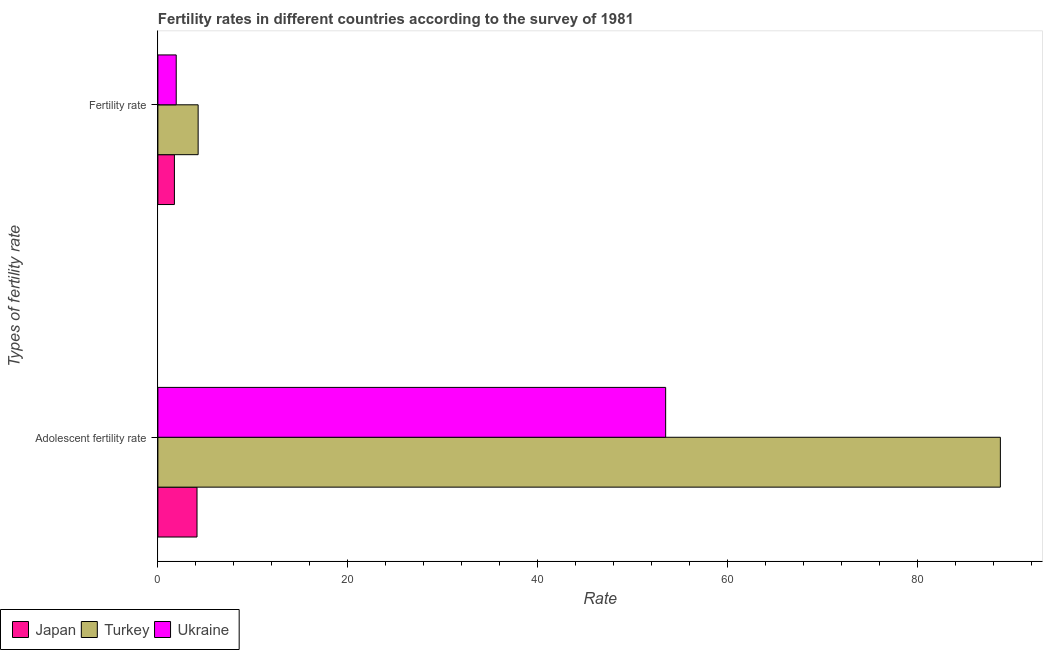How many different coloured bars are there?
Your answer should be very brief. 3. How many groups of bars are there?
Provide a short and direct response. 2. Are the number of bars on each tick of the Y-axis equal?
Provide a succinct answer. Yes. How many bars are there on the 1st tick from the bottom?
Provide a short and direct response. 3. What is the label of the 2nd group of bars from the top?
Your answer should be very brief. Adolescent fertility rate. What is the fertility rate in Turkey?
Ensure brevity in your answer.  4.24. Across all countries, what is the maximum fertility rate?
Offer a terse response. 4.24. Across all countries, what is the minimum fertility rate?
Provide a short and direct response. 1.74. In which country was the adolescent fertility rate maximum?
Your answer should be compact. Turkey. What is the total fertility rate in the graph?
Offer a terse response. 7.91. What is the difference between the fertility rate in Japan and that in Turkey?
Make the answer very short. -2.5. What is the difference between the adolescent fertility rate in Japan and the fertility rate in Turkey?
Give a very brief answer. -0.12. What is the average adolescent fertility rate per country?
Provide a succinct answer. 48.78. What is the difference between the fertility rate and adolescent fertility rate in Japan?
Give a very brief answer. -2.38. What is the ratio of the adolescent fertility rate in Ukraine to that in Turkey?
Offer a terse response. 0.6. Is the fertility rate in Japan less than that in Turkey?
Your response must be concise. Yes. What does the 3rd bar from the top in Adolescent fertility rate represents?
Keep it short and to the point. Japan. What does the 3rd bar from the bottom in Adolescent fertility rate represents?
Provide a succinct answer. Ukraine. What is the difference between two consecutive major ticks on the X-axis?
Make the answer very short. 20. Are the values on the major ticks of X-axis written in scientific E-notation?
Offer a terse response. No. Does the graph contain grids?
Make the answer very short. No. Where does the legend appear in the graph?
Offer a very short reply. Bottom left. How many legend labels are there?
Ensure brevity in your answer.  3. How are the legend labels stacked?
Your answer should be very brief. Horizontal. What is the title of the graph?
Your response must be concise. Fertility rates in different countries according to the survey of 1981. What is the label or title of the X-axis?
Provide a short and direct response. Rate. What is the label or title of the Y-axis?
Provide a succinct answer. Types of fertility rate. What is the Rate in Japan in Adolescent fertility rate?
Your answer should be compact. 4.12. What is the Rate in Turkey in Adolescent fertility rate?
Your response must be concise. 88.73. What is the Rate in Ukraine in Adolescent fertility rate?
Provide a succinct answer. 53.48. What is the Rate in Japan in Fertility rate?
Your response must be concise. 1.74. What is the Rate of Turkey in Fertility rate?
Keep it short and to the point. 4.24. What is the Rate in Ukraine in Fertility rate?
Keep it short and to the point. 1.93. Across all Types of fertility rate, what is the maximum Rate of Japan?
Ensure brevity in your answer.  4.12. Across all Types of fertility rate, what is the maximum Rate in Turkey?
Ensure brevity in your answer.  88.73. Across all Types of fertility rate, what is the maximum Rate of Ukraine?
Make the answer very short. 53.48. Across all Types of fertility rate, what is the minimum Rate in Japan?
Your answer should be compact. 1.74. Across all Types of fertility rate, what is the minimum Rate in Turkey?
Provide a succinct answer. 4.24. Across all Types of fertility rate, what is the minimum Rate of Ukraine?
Your response must be concise. 1.93. What is the total Rate in Japan in the graph?
Ensure brevity in your answer.  5.86. What is the total Rate in Turkey in the graph?
Ensure brevity in your answer.  92.97. What is the total Rate of Ukraine in the graph?
Offer a very short reply. 55.41. What is the difference between the Rate of Japan in Adolescent fertility rate and that in Fertility rate?
Ensure brevity in your answer.  2.38. What is the difference between the Rate in Turkey in Adolescent fertility rate and that in Fertility rate?
Offer a terse response. 84.5. What is the difference between the Rate of Ukraine in Adolescent fertility rate and that in Fertility rate?
Ensure brevity in your answer.  51.55. What is the difference between the Rate in Japan in Adolescent fertility rate and the Rate in Turkey in Fertility rate?
Offer a terse response. -0.12. What is the difference between the Rate in Japan in Adolescent fertility rate and the Rate in Ukraine in Fertility rate?
Your response must be concise. 2.19. What is the difference between the Rate of Turkey in Adolescent fertility rate and the Rate of Ukraine in Fertility rate?
Offer a very short reply. 86.8. What is the average Rate in Japan per Types of fertility rate?
Your response must be concise. 2.93. What is the average Rate of Turkey per Types of fertility rate?
Provide a succinct answer. 46.49. What is the average Rate of Ukraine per Types of fertility rate?
Keep it short and to the point. 27.71. What is the difference between the Rate in Japan and Rate in Turkey in Adolescent fertility rate?
Offer a very short reply. -84.61. What is the difference between the Rate in Japan and Rate in Ukraine in Adolescent fertility rate?
Ensure brevity in your answer.  -49.36. What is the difference between the Rate of Turkey and Rate of Ukraine in Adolescent fertility rate?
Offer a very short reply. 35.25. What is the difference between the Rate of Japan and Rate of Turkey in Fertility rate?
Offer a very short reply. -2.5. What is the difference between the Rate in Japan and Rate in Ukraine in Fertility rate?
Your response must be concise. -0.19. What is the difference between the Rate in Turkey and Rate in Ukraine in Fertility rate?
Your answer should be very brief. 2.31. What is the ratio of the Rate in Japan in Adolescent fertility rate to that in Fertility rate?
Ensure brevity in your answer.  2.37. What is the ratio of the Rate in Turkey in Adolescent fertility rate to that in Fertility rate?
Make the answer very short. 20.93. What is the ratio of the Rate in Ukraine in Adolescent fertility rate to that in Fertility rate?
Your response must be concise. 27.71. What is the difference between the highest and the second highest Rate of Japan?
Your answer should be compact. 2.38. What is the difference between the highest and the second highest Rate of Turkey?
Ensure brevity in your answer.  84.5. What is the difference between the highest and the second highest Rate in Ukraine?
Your answer should be very brief. 51.55. What is the difference between the highest and the lowest Rate in Japan?
Your answer should be very brief. 2.38. What is the difference between the highest and the lowest Rate in Turkey?
Give a very brief answer. 84.5. What is the difference between the highest and the lowest Rate in Ukraine?
Provide a short and direct response. 51.55. 